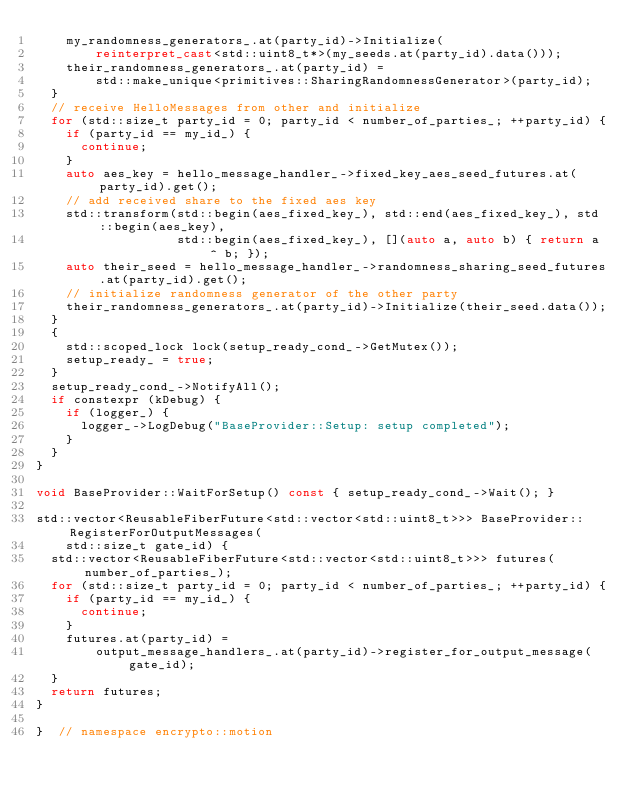Convert code to text. <code><loc_0><loc_0><loc_500><loc_500><_C++_>    my_randomness_generators_.at(party_id)->Initialize(
        reinterpret_cast<std::uint8_t*>(my_seeds.at(party_id).data()));
    their_randomness_generators_.at(party_id) =
        std::make_unique<primitives::SharingRandomnessGenerator>(party_id);
  }
  // receive HelloMessages from other and initialize
  for (std::size_t party_id = 0; party_id < number_of_parties_; ++party_id) {
    if (party_id == my_id_) {
      continue;
    }
    auto aes_key = hello_message_handler_->fixed_key_aes_seed_futures.at(party_id).get();
    // add received share to the fixed aes key
    std::transform(std::begin(aes_fixed_key_), std::end(aes_fixed_key_), std::begin(aes_key),
                   std::begin(aes_fixed_key_), [](auto a, auto b) { return a ^ b; });
    auto their_seed = hello_message_handler_->randomness_sharing_seed_futures.at(party_id).get();
    // initialize randomness generator of the other party
    their_randomness_generators_.at(party_id)->Initialize(their_seed.data());
  }
  {
    std::scoped_lock lock(setup_ready_cond_->GetMutex());
    setup_ready_ = true;
  }
  setup_ready_cond_->NotifyAll();
  if constexpr (kDebug) {
    if (logger_) {
      logger_->LogDebug("BaseProvider::Setup: setup completed");
    }
  }
}

void BaseProvider::WaitForSetup() const { setup_ready_cond_->Wait(); }

std::vector<ReusableFiberFuture<std::vector<std::uint8_t>>> BaseProvider::RegisterForOutputMessages(
    std::size_t gate_id) {
  std::vector<ReusableFiberFuture<std::vector<std::uint8_t>>> futures(number_of_parties_);
  for (std::size_t party_id = 0; party_id < number_of_parties_; ++party_id) {
    if (party_id == my_id_) {
      continue;
    }
    futures.at(party_id) =
        output_message_handlers_.at(party_id)->register_for_output_message(gate_id);
  }
  return futures;
}

}  // namespace encrypto::motion
</code> 